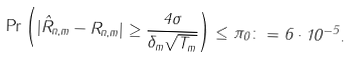Convert formula to latex. <formula><loc_0><loc_0><loc_500><loc_500>\Pr \left ( | \hat { R } _ { n , m } - R _ { n , m } | \geq \frac { 4 \sigma } { \delta _ { m } \sqrt { T _ { m } } } \right ) \leq \pi _ { 0 } \colon = 6 \cdot 1 0 ^ { - 5 } .</formula> 